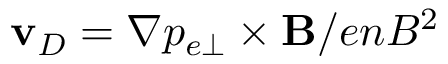Convert formula to latex. <formula><loc_0><loc_0><loc_500><loc_500>v _ { D } = \nabla p _ { e \perp } \times B / e n B ^ { 2 }</formula> 